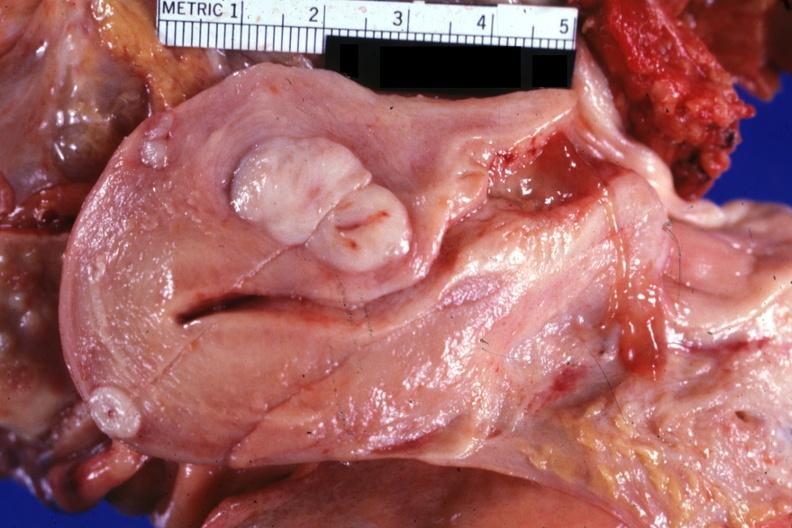what is present?
Answer the question using a single word or phrase. Female reproductive 